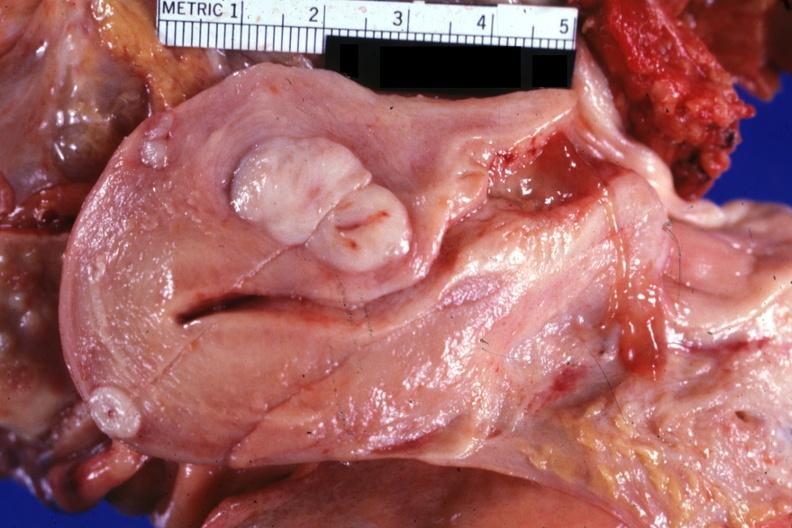what is present?
Answer the question using a single word or phrase. Female reproductive 